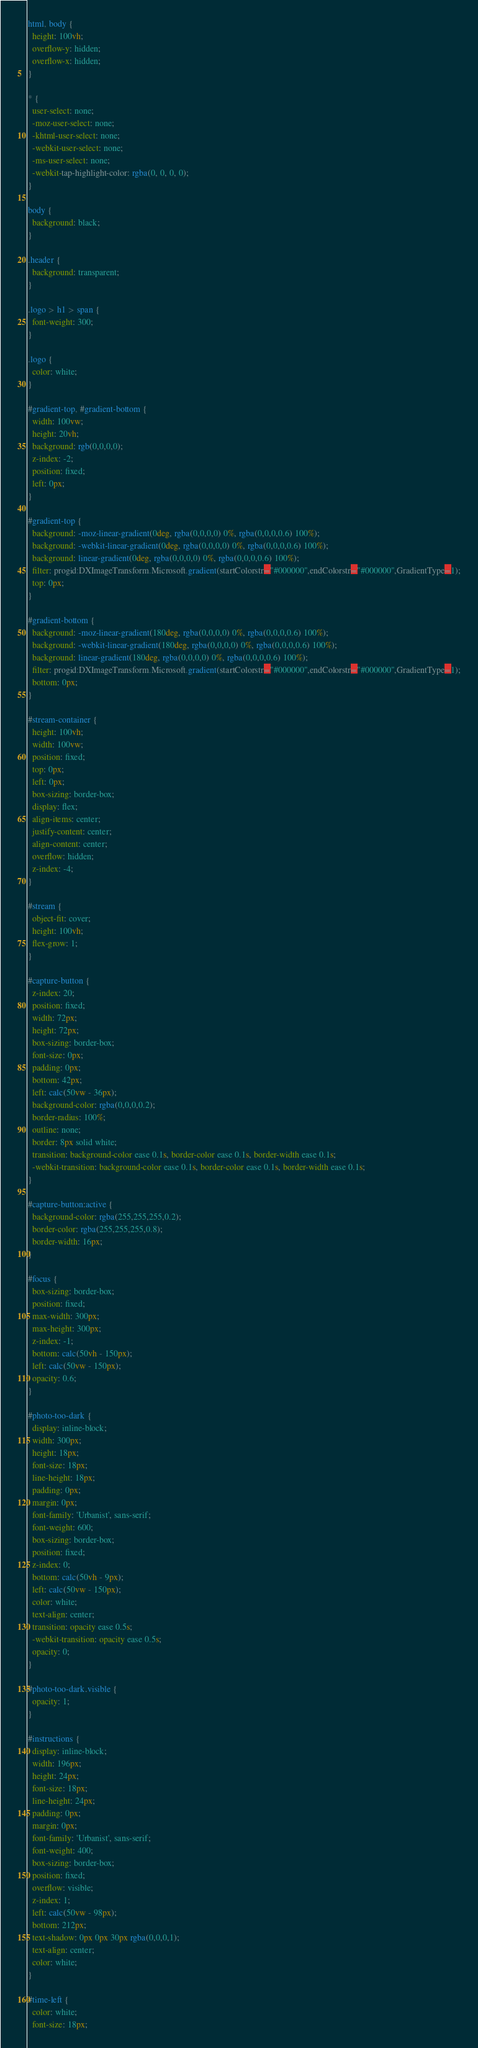<code> <loc_0><loc_0><loc_500><loc_500><_CSS_>html, body {
  height: 100vh;
  overflow-y: hidden;
  overflow-x: hidden;
}

* {
  user-select: none;
  -moz-user-select: none;
  -khtml-user-select: none;
  -webkit-user-select: none;
  -ms-user-select: none;
  -webkit-tap-highlight-color: rgba(0, 0, 0, 0);
}

body {
  background: black;
}

.header {
  background: transparent;
}

.logo > h1 > span {
  font-weight: 300;
}

.logo {
  color: white;
}

#gradient-top, #gradient-bottom {
  width: 100vw;
  height: 20vh;
  background: rgb(0,0,0,0);
  z-index: -2;
  position: fixed;
  left: 0px;
}

#gradient-top {
  background: -moz-linear-gradient(0deg, rgba(0,0,0,0) 0%, rgba(0,0,0,0.6) 100%);
  background: -webkit-linear-gradient(0deg, rgba(0,0,0,0) 0%, rgba(0,0,0,0.6) 100%);
  background: linear-gradient(0deg, rgba(0,0,0,0) 0%, rgba(0,0,0,0.6) 100%);
  filter: progid:DXImageTransform.Microsoft.gradient(startColorstr="#000000",endColorstr="#000000",GradientType=1);
  top: 0px;
}

#gradient-bottom {
  background: -moz-linear-gradient(180deg, rgba(0,0,0,0) 0%, rgba(0,0,0,0.6) 100%);
  background: -webkit-linear-gradient(180deg, rgba(0,0,0,0) 0%, rgba(0,0,0,0.6) 100%);
  background: linear-gradient(180deg, rgba(0,0,0,0) 0%, rgba(0,0,0,0.6) 100%);
  filter: progid:DXImageTransform.Microsoft.gradient(startColorstr="#000000",endColorstr="#000000",GradientType=1);
  bottom: 0px;
}

#stream-container {
  height: 100vh;
  width: 100vw;
  position: fixed;
  top: 0px;
  left: 0px;
  box-sizing: border-box;
  display: flex;
  align-items: center;
  justify-content: center;
  align-content: center;
  overflow: hidden;
  z-index: -4;
}

#stream {
  object-fit: cover;
  height: 100vh;
  flex-grow: 1;
}

#capture-button {
  z-index: 20;
  position: fixed;
  width: 72px;
  height: 72px;
  box-sizing: border-box;
  font-size: 0px;
  padding: 0px;
  bottom: 42px;
  left: calc(50vw - 36px);
  background-color: rgba(0,0,0,0.2);
  border-radius: 100%;
  outline: none;
  border: 8px solid white;
  transition: background-color ease 0.1s, border-color ease 0.1s, border-width ease 0.1s;
  -webkit-transition: background-color ease 0.1s, border-color ease 0.1s, border-width ease 0.1s;
}

#capture-button:active {
  background-color: rgba(255,255,255,0.2);
  border-color: rgba(255,255,255,0.8);
  border-width: 16px;
}

#focus {
  box-sizing: border-box;
  position: fixed;
  max-width: 300px;
  max-height: 300px;
  z-index: -1;
  bottom: calc(50vh - 150px);
  left: calc(50vw - 150px);
  opacity: 0.6;
}

#photo-too-dark {
  display: inline-block;
  width: 300px;
  height: 18px;
  font-size: 18px;
  line-height: 18px;
  padding: 0px;
  margin: 0px;
  font-family: 'Urbanist', sans-serif;
  font-weight: 600;
  box-sizing: border-box;
  position: fixed;
  z-index: 0;
  bottom: calc(50vh - 9px);
  left: calc(50vw - 150px);
  color: white;
  text-align: center;
  transition: opacity ease 0.5s;
  -webkit-transition: opacity ease 0.5s;
  opacity: 0;
}

#photo-too-dark.visible {
  opacity: 1;
}

#instructions {
  display: inline-block;
  width: 196px;
  height: 24px;
  font-size: 18px;
  line-height: 24px;
  padding: 0px;
  margin: 0px;
  font-family: 'Urbanist', sans-serif;
  font-weight: 400;
  box-sizing: border-box;
  position: fixed;
  overflow: visible;
  z-index: 1;
  left: calc(50vw - 98px);
  bottom: 212px;
  text-shadow: 0px 0px 30px rgba(0,0,0,1);
  text-align: center;
  color: white;
}

#time-left {
  color: white;
  font-size: 18px;</code> 